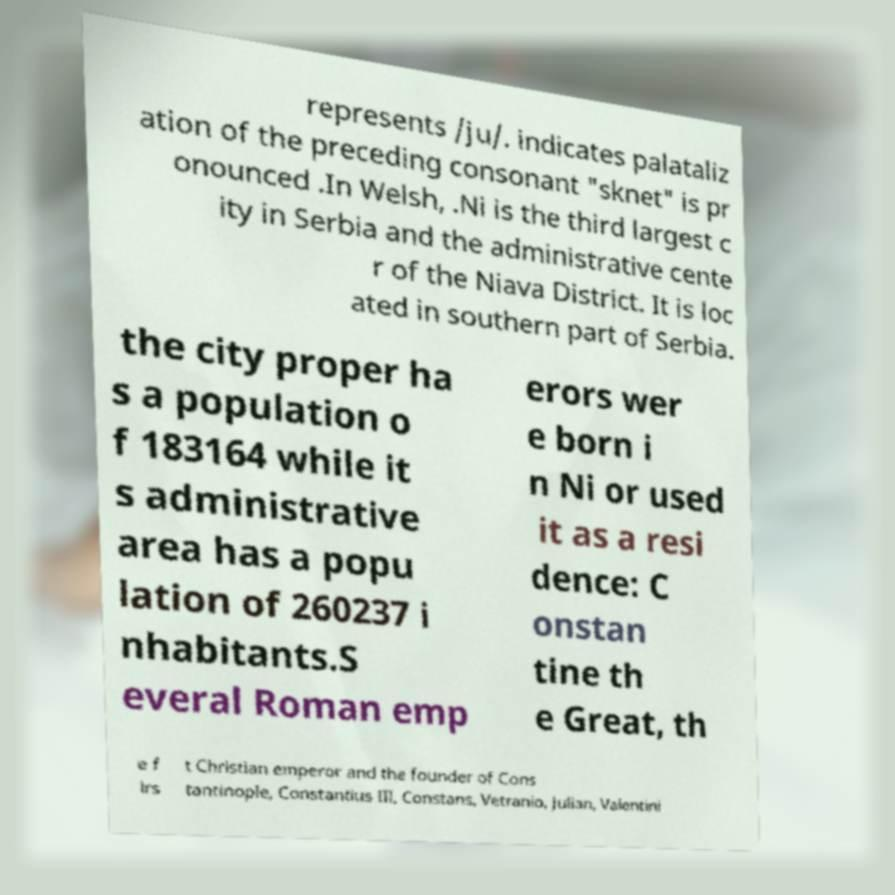Can you accurately transcribe the text from the provided image for me? represents /ju/. indicates palataliz ation of the preceding consonant "sknet" is pr onounced .In Welsh, .Ni is the third largest c ity in Serbia and the administrative cente r of the Niava District. It is loc ated in southern part of Serbia. the city proper ha s a population o f 183164 while it s administrative area has a popu lation of 260237 i nhabitants.S everal Roman emp erors wer e born i n Ni or used it as a resi dence: C onstan tine th e Great, th e f irs t Christian emperor and the founder of Cons tantinople, Constantius III, Constans, Vetranio, Julian, Valentini 